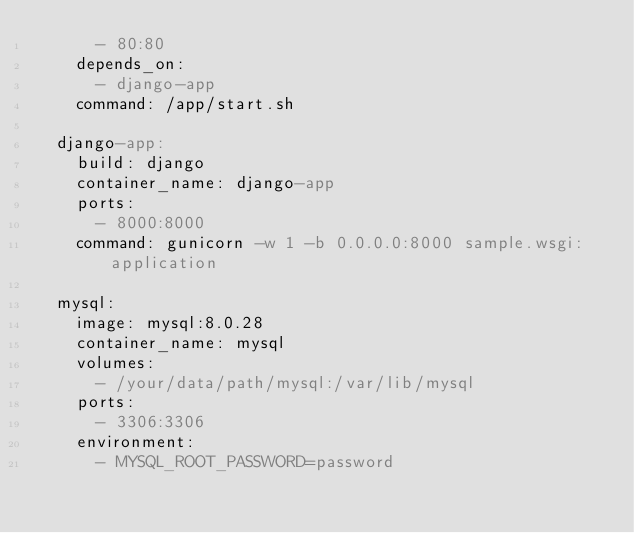Convert code to text. <code><loc_0><loc_0><loc_500><loc_500><_YAML_>      - 80:80
    depends_on:
      - django-app
    command: /app/start.sh
  
  django-app:
    build: django
    container_name: django-app
    ports:
      - 8000:8000
    command: gunicorn -w 1 -b 0.0.0.0:8000 sample.wsgi:application
  
  mysql:
    image: mysql:8.0.28
    container_name: mysql
    volumes:
      - /your/data/path/mysql:/var/lib/mysql
    ports:
      - 3306:3306
    environment:
      - MYSQL_ROOT_PASSWORD=password


</code> 